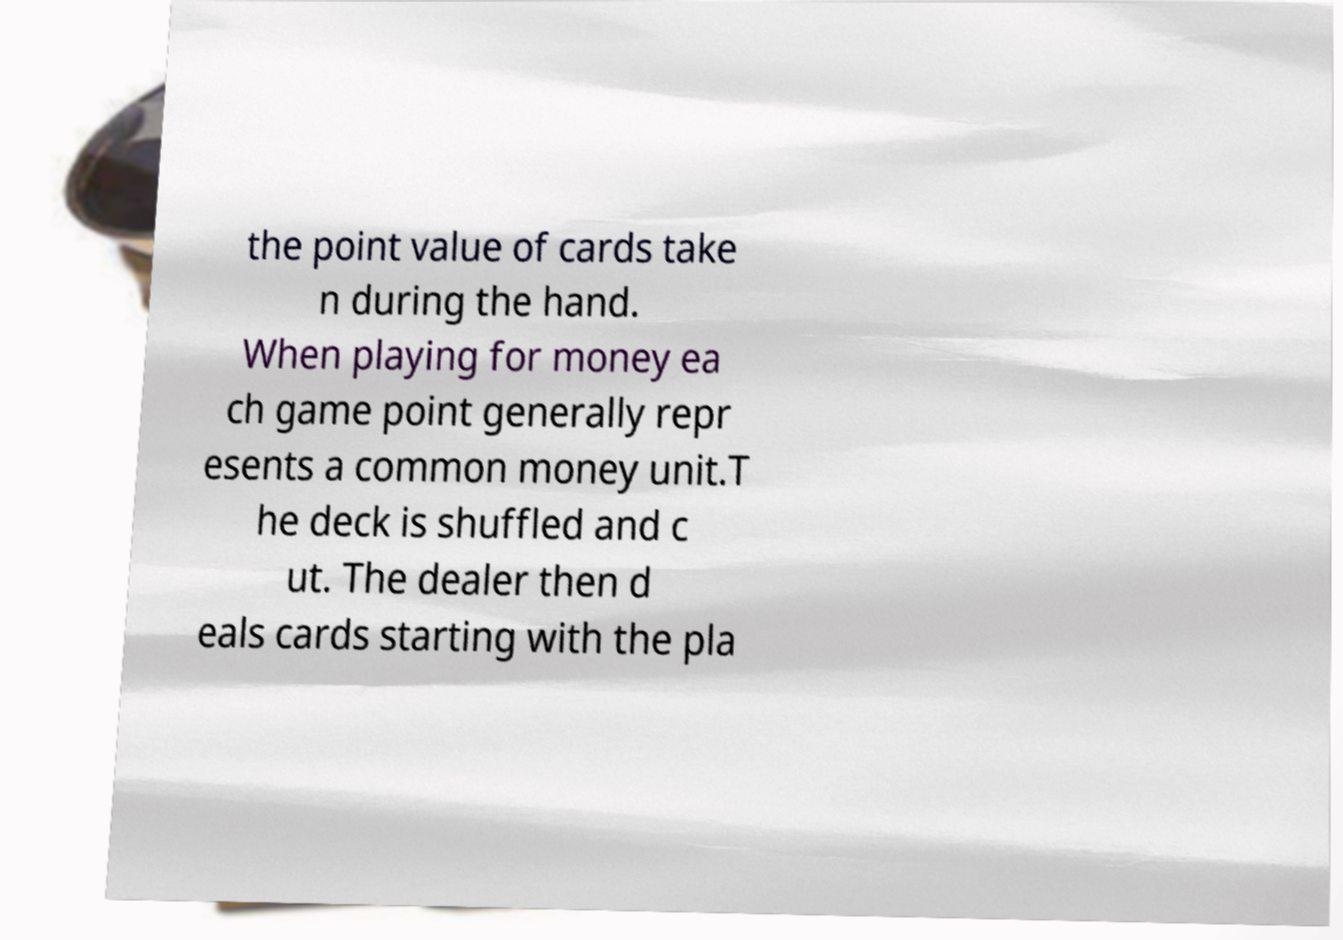Can you accurately transcribe the text from the provided image for me? the point value of cards take n during the hand. When playing for money ea ch game point generally repr esents a common money unit.T he deck is shuffled and c ut. The dealer then d eals cards starting with the pla 